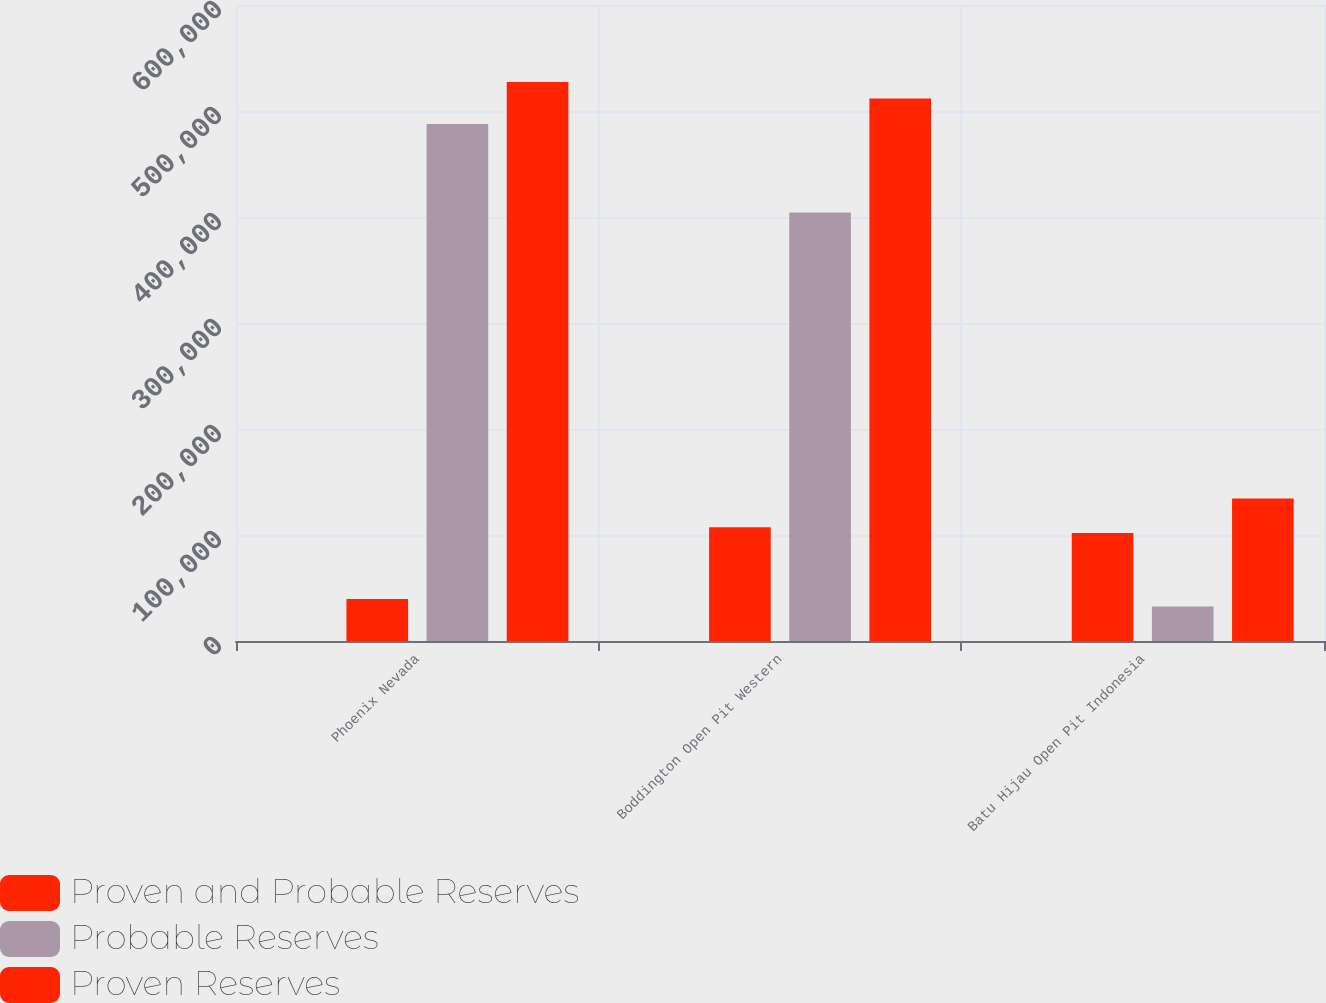<chart> <loc_0><loc_0><loc_500><loc_500><stacked_bar_chart><ecel><fcel>Phoenix Nevada<fcel>Boddington Open Pit Western<fcel>Batu Hijau Open Pit Indonesia<nl><fcel>nan<fcel>100<fcel>100<fcel>48.5<nl><fcel>Proven and Probable Reserves<fcel>39700<fcel>107400<fcel>101900<nl><fcel>Probable Reserves<fcel>487700<fcel>404300<fcel>32600<nl><fcel>Proven Reserves<fcel>527400<fcel>511700<fcel>134500<nl></chart> 